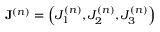<formula> <loc_0><loc_0><loc_500><loc_500>J ^ { ( n ) } = \left ( J _ { 1 } ^ { ( n ) } , J _ { 2 } ^ { ( n ) } , J _ { 3 } ^ { ( n ) } \right )</formula> 